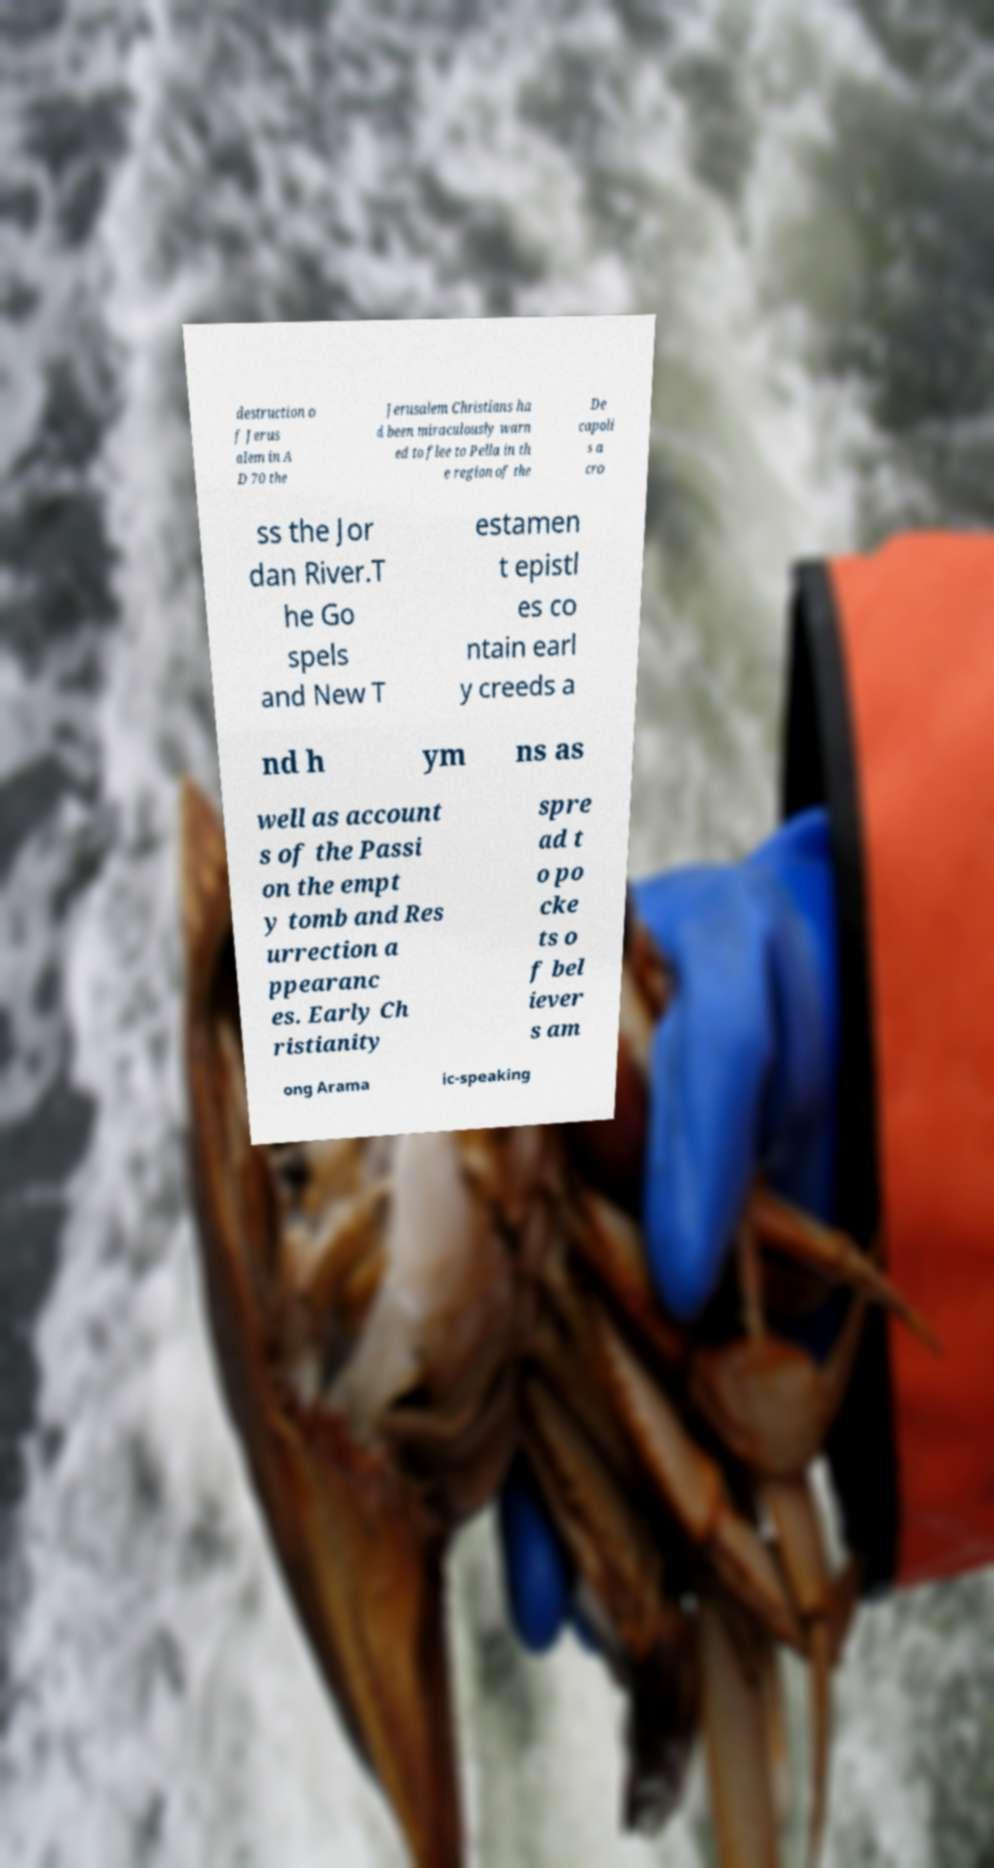Can you accurately transcribe the text from the provided image for me? destruction o f Jerus alem in A D 70 the Jerusalem Christians ha d been miraculously warn ed to flee to Pella in th e region of the De capoli s a cro ss the Jor dan River.T he Go spels and New T estamen t epistl es co ntain earl y creeds a nd h ym ns as well as account s of the Passi on the empt y tomb and Res urrection a ppearanc es. Early Ch ristianity spre ad t o po cke ts o f bel iever s am ong Arama ic-speaking 